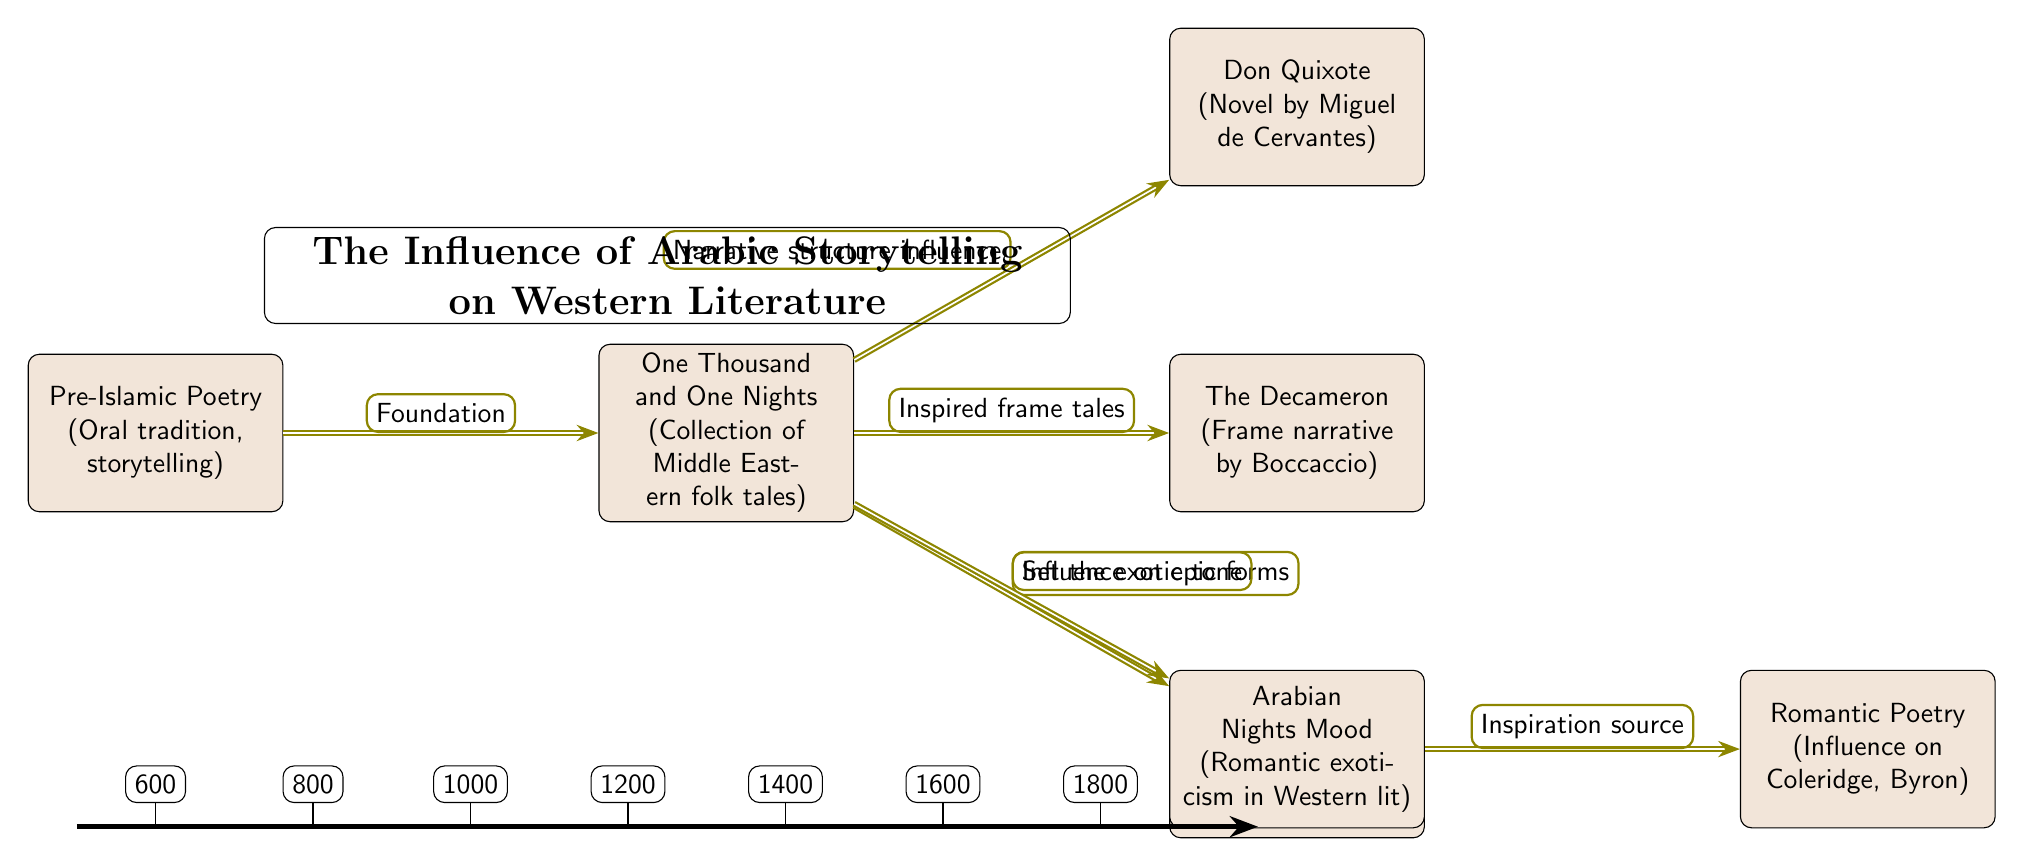What is the earliest text represented in the diagram? The earliest text in the diagram is Pre-Islamic Poetry, which is placed at the leftmost position indicating its origin prior to the other texts.
Answer: Pre-Islamic Poetry How many influences are shown stemming from One Thousand and One Nights? The diagram shows five influences stemming from One Thousand and One Nights, as indicated by the five edges connecting it to other nodes.
Answer: Five Which text is labeled as a frame narrative? The Decameron is labeled as a frame narrative, as indicated by the description provided in the node.
Answer: The Decameron What theme is associated with Arabian Nights Mood? The theme associated with Arabian Nights Mood is "Romantic exoticism in Western lit," as noted in the description of that node.
Answer: Romantic exoticism in Western lit Which Western text is influenced by One Thousand and One Nights through narrative structure? Don Quixote is influenced by One Thousand and One Nights through narrative structure, according to the edge label that connects them in the diagram.
Answer: Don Quixote Which key text had the influence of providing the foundation for One Thousand and One Nights? The foundation for One Thousand and One Nights is attributed to Pre-Islamic Poetry, as shown by the directed edge flowing from it.
Answer: Pre-Islamic Poetry What is the time span indicated in the diagram (in years)? The time span shown in the diagram covers from 600 to 1800, as indicated on the timeline at the bottom of the diagram.
Answer: 1200 Which poets were influenced by Romantic Poetry according to the diagram? The poets influenced by Romantic Poetry include Coleridge and Byron, as described in the corresponding node.
Answer: Coleridge, Byron How many nodes appear in the diagram? There are a total of seven nodes in the diagram representing different texts and themes, including the title node.
Answer: Seven 